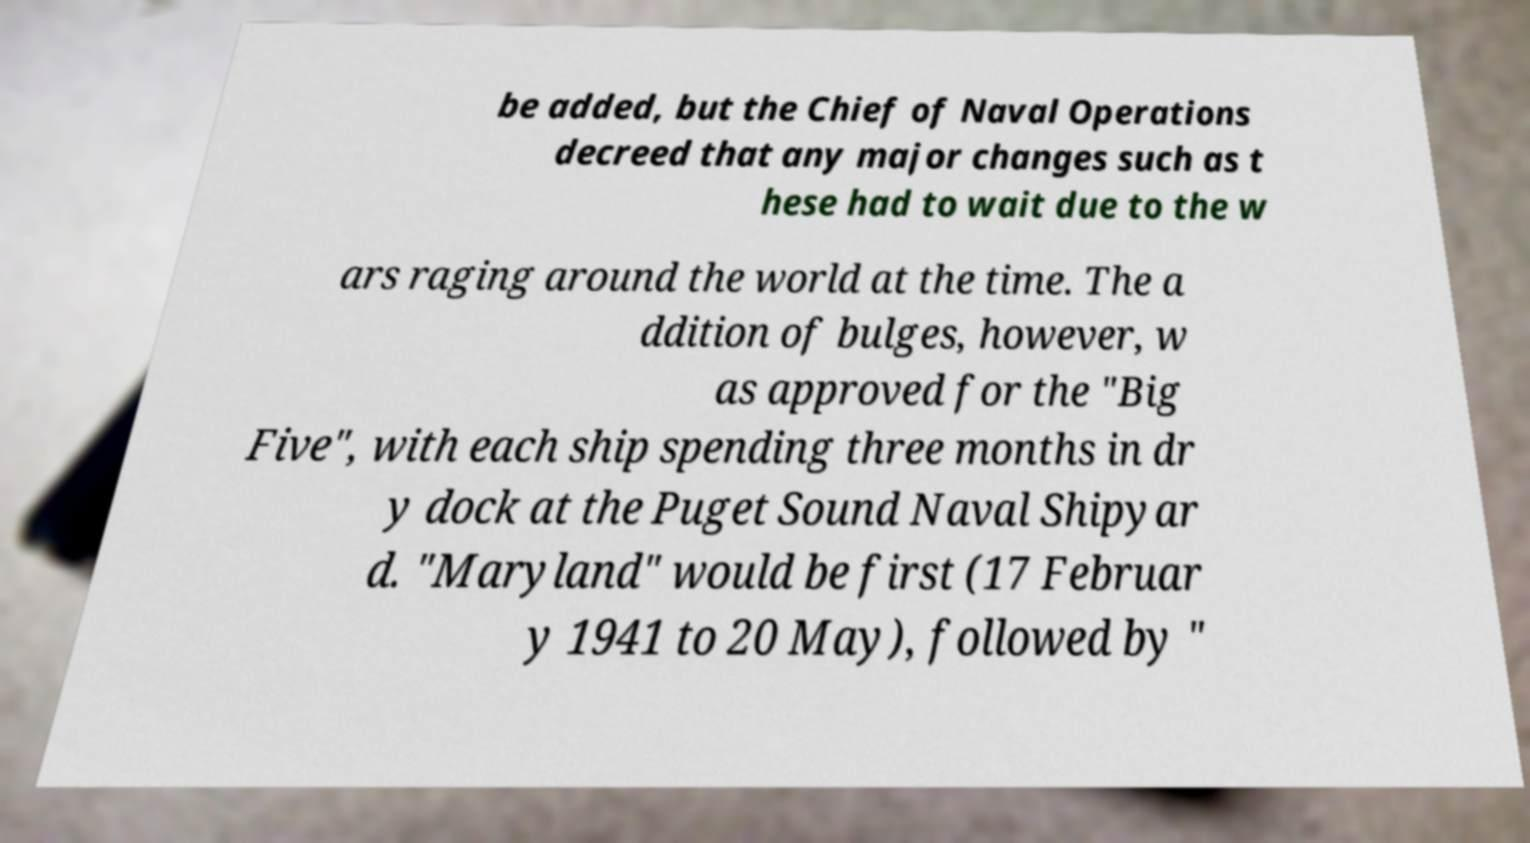Please identify and transcribe the text found in this image. be added, but the Chief of Naval Operations decreed that any major changes such as t hese had to wait due to the w ars raging around the world at the time. The a ddition of bulges, however, w as approved for the "Big Five", with each ship spending three months in dr y dock at the Puget Sound Naval Shipyar d. "Maryland" would be first (17 Februar y 1941 to 20 May), followed by " 